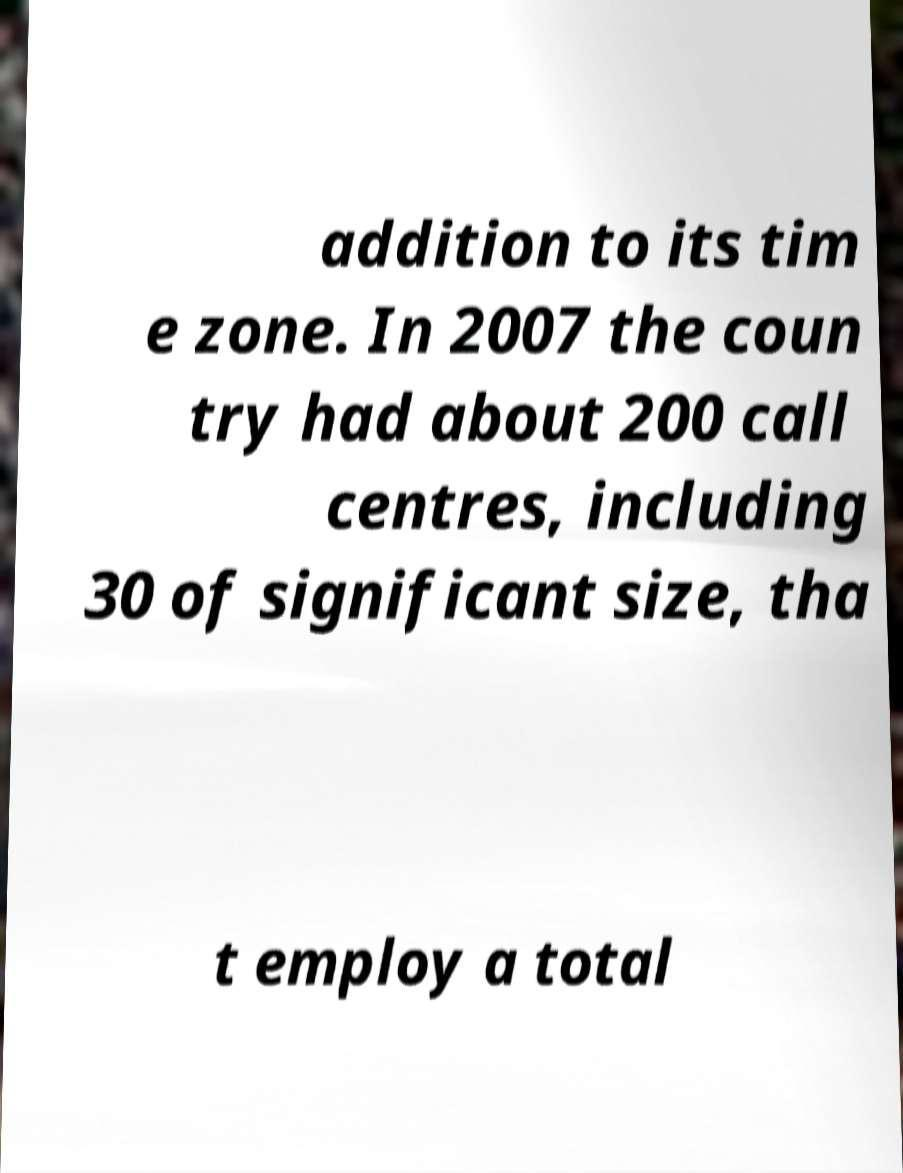For documentation purposes, I need the text within this image transcribed. Could you provide that? addition to its tim e zone. In 2007 the coun try had about 200 call centres, including 30 of significant size, tha t employ a total 